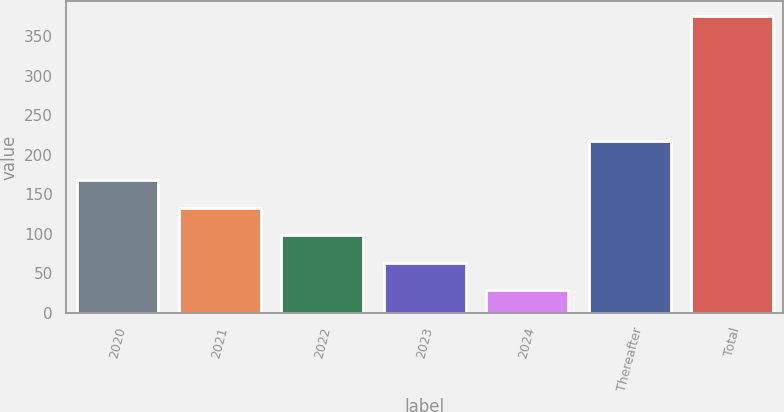Convert chart to OTSL. <chart><loc_0><loc_0><loc_500><loc_500><bar_chart><fcel>2020<fcel>2021<fcel>2022<fcel>2023<fcel>2024<fcel>Thereafter<fcel>Total<nl><fcel>167.32<fcel>132.64<fcel>97.96<fcel>63.28<fcel>28.6<fcel>217.6<fcel>375.4<nl></chart> 